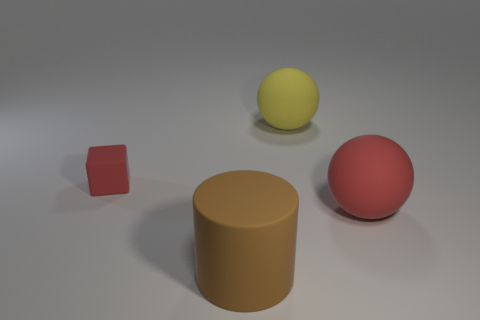Could you tell me the possible purpose of arranging these objects in this manner? The arrangement of objects could be a part of a visual composition exercise demonstrating different geometrical shapes and colors, or it could be for a study of how light and shadow interact with objects of varying textures and surfaces. 